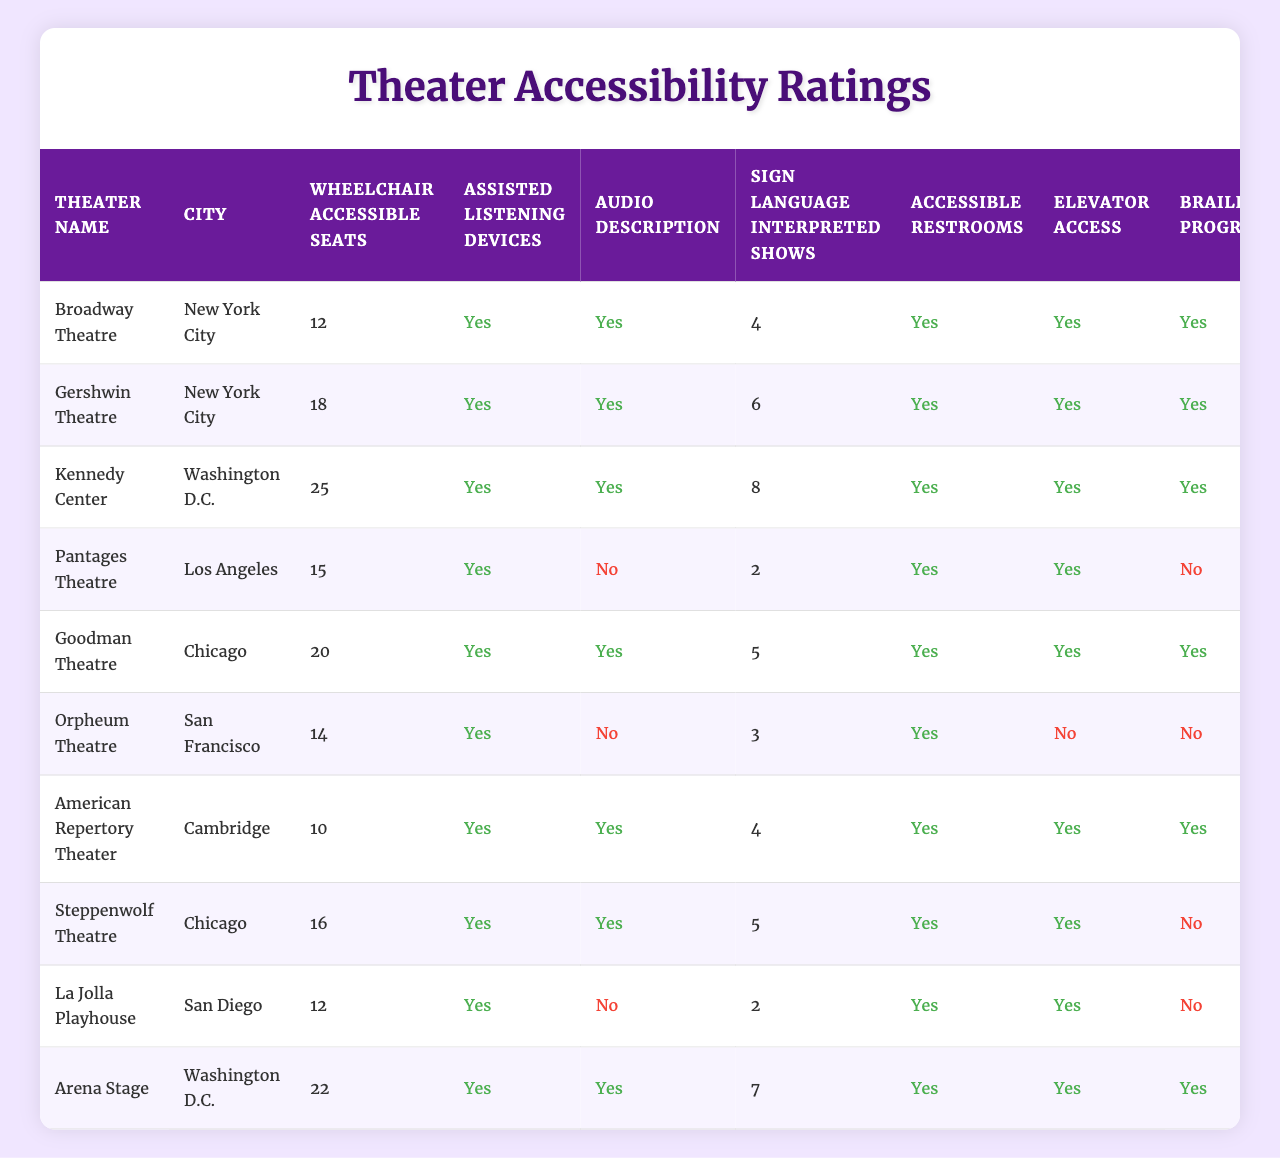What is the overall accessibility rating of the Goodman Theatre? The overall accessibility rating of the Goodman Theatre, as noted in the table, is 4.7.
Answer: 4.7 Which theater has the highest number of wheelchair accessible seats? By comparing the number of wheelchair accessible seats listed for each theater, the Kennedy Center has the highest count with 25 seats.
Answer: Kennedy Center Is there audio description available at the Pantages Theatre? According to the information provided in the table, the Pantages Theatre does not offer audio description services, indicated by "No" under the audio description column.
Answer: No How many theaters offer sign language interpreted shows? By reviewing the data, we can tally the number of theaters that provide sign language interpreted shows. The counts for each are: 4 (Broadway Theatre), 6 (Gershwin Theatre), 8 (Kennedy Center), 2 (Pantages Theatre), 5 (Goodman Theatre), 3 (Orpheum Theatre), 4 (American Repertory Theater), 5 (Steppenwolf Theatre), 2 (La Jolla Playhouse), and 7 (Arena Stage). Adding these gives a total of 42 counted shows. Hence, there are 10 theaters listed here.
Answer: 10 Which city has a theater with the lowest overall accessibility rating? Looking at the overall accessibility ratings by city, the Orpheum Theatre in San Francisco holds the lowest rating of 3.5 among all theaters listed.
Answer: San Francisco What is the average number of sign language interpreted shows across all theaters? To find the average number, first sum the values of sign language interpreted shows: 4 + 6 + 8 + 2 + 5 + 3 + 4 + 5 + 2 + 7 = 42. Then divide by the number of theaters, which is 10, resulting in an average of 42/10 = 4.2.
Answer: 4.2 Are there any theaters that do not have elevator access? By examining the elevator access column, we see that the Orpheum Theatre in San Francisco does not have elevator access, as listed by "No" under that specific column.
Answer: Yes Which theater in New York City offers the highest overall accessibility rating? After identifying the theaters in New York City (Broadway Theatre and Gershwin Theatre), we find their accessibility ratings are 4.5 and 4.8 respectively. Therefore, the Gershwin Theatre has the highest rating.
Answer: Gershwin Theatre How many theaters have both audio description and braille programs available? Evaluating the table, we look for theaters that have both "Yes" in the audio description and braille programs. Those are Broadway Theatre, Gershwin Theatre, Kennedy Center, and American Repertory Theater, giving us a total of 4 theaters.
Answer: 4 Which theater has the second highest number of accessible restrooms available? The table states that all theaters have accessible restrooms available, indicated by "Yes". Therefore, we look at other features, and refer to the overall accessibility rating. The theater with the second highest rating after the Kennedy Center is the Gershwin Theatre, with a rating of 4.8.
Answer: Gershwin Theatre 